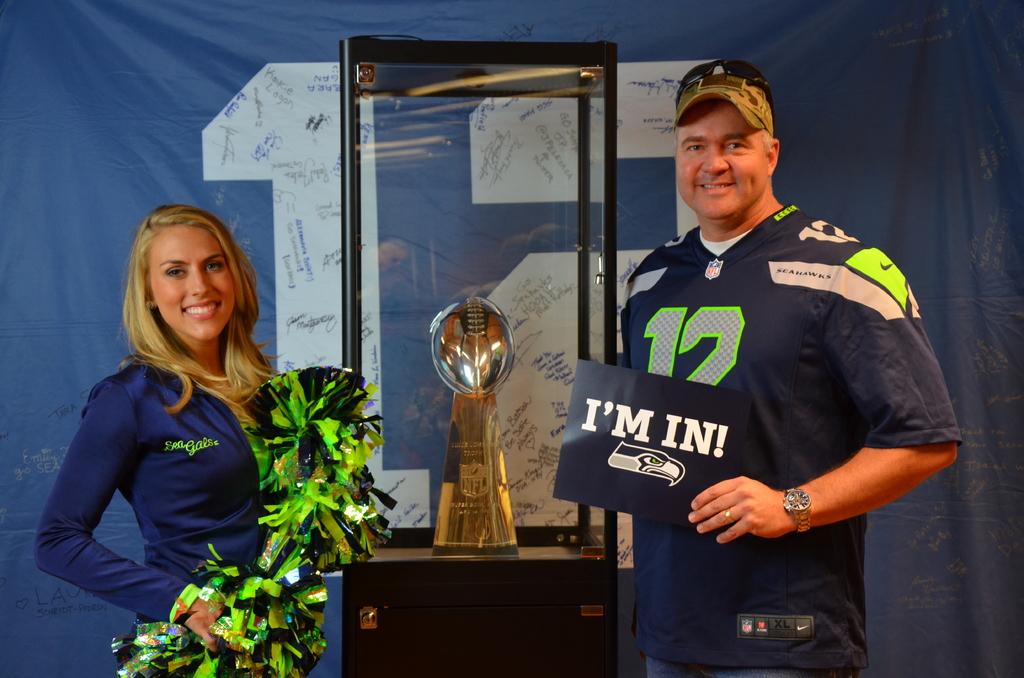What does the man's sign say?
Provide a succinct answer. I'm in!. What number is on the jersey?
Your answer should be compact. 12. 